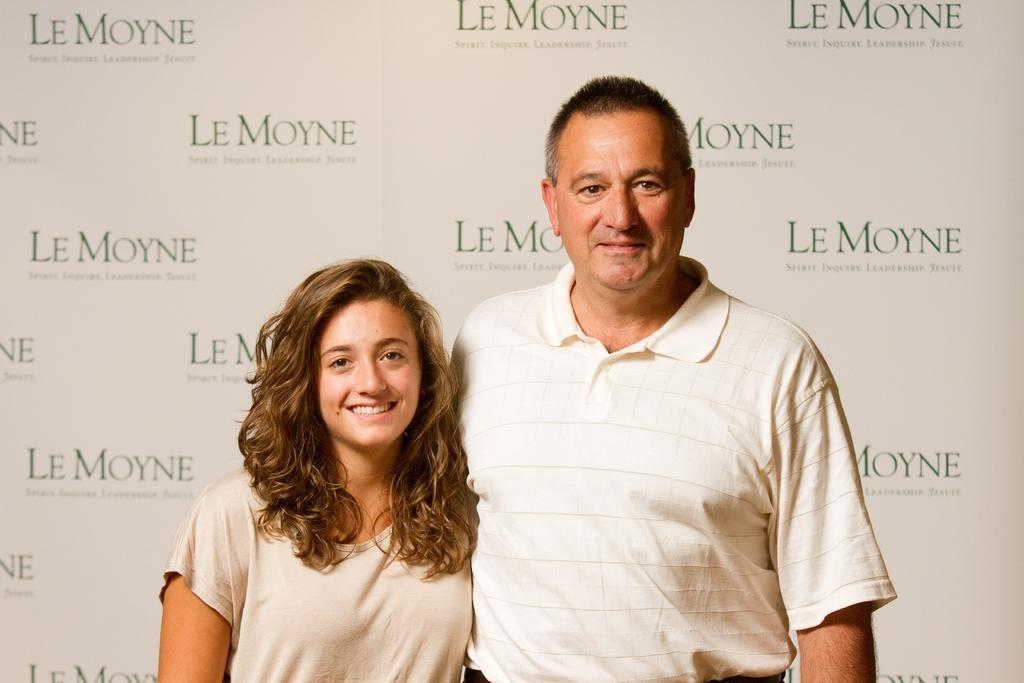How many people are in the image? There are two persons in the image. What are the persons doing in the image? The persons are standing. What are the persons wearing in the image? The persons are wearing clothes. What type of bird can be seen perched on the gate in the image? There is no gate or bird present in the image. What is the porter carrying in the image? There is no porter or any object being carried in the image. 